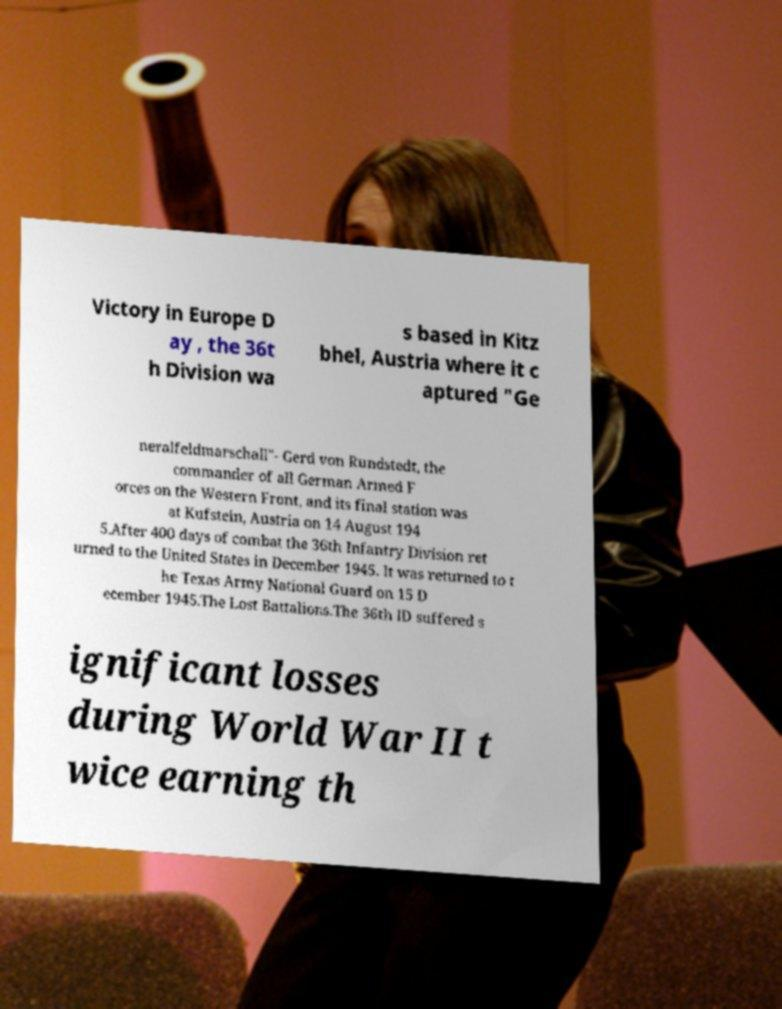Could you extract and type out the text from this image? Victory in Europe D ay , the 36t h Division wa s based in Kitz bhel, Austria where it c aptured "Ge neralfeldmarschall"- Gerd von Rundstedt, the commander of all German Armed F orces on the Western Front, and its final station was at Kufstein, Austria on 14 August 194 5.After 400 days of combat the 36th Infantry Division ret urned to the United States in December 1945. It was returned to t he Texas Army National Guard on 15 D ecember 1945.The Lost Battalions.The 36th ID suffered s ignificant losses during World War II t wice earning th 